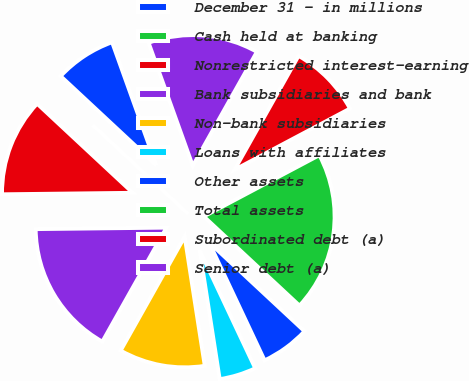Convert chart. <chart><loc_0><loc_0><loc_500><loc_500><pie_chart><fcel>December 31 - in millions<fcel>Cash held at banking<fcel>Nonrestricted interest-earning<fcel>Bank subsidiaries and bank<fcel>Non-bank subsidiaries<fcel>Loans with affiliates<fcel>Other assets<fcel>Total assets<fcel>Subordinated debt (a)<fcel>Senior debt (a)<nl><fcel>7.58%<fcel>0.0%<fcel>12.12%<fcel>16.67%<fcel>10.61%<fcel>4.55%<fcel>6.06%<fcel>19.7%<fcel>9.09%<fcel>13.64%<nl></chart> 